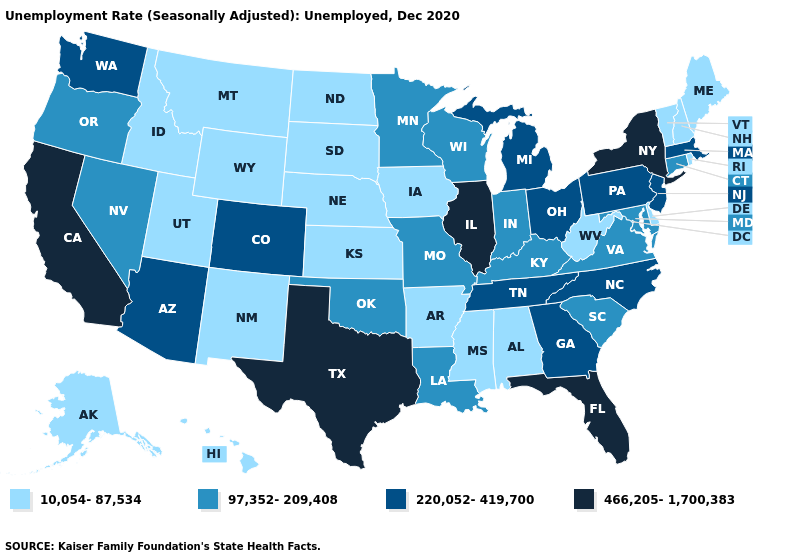Among the states that border Illinois , does Iowa have the lowest value?
Concise answer only. Yes. Name the states that have a value in the range 220,052-419,700?
Short answer required. Arizona, Colorado, Georgia, Massachusetts, Michigan, New Jersey, North Carolina, Ohio, Pennsylvania, Tennessee, Washington. What is the lowest value in states that border Missouri?
Concise answer only. 10,054-87,534. Name the states that have a value in the range 97,352-209,408?
Give a very brief answer. Connecticut, Indiana, Kentucky, Louisiana, Maryland, Minnesota, Missouri, Nevada, Oklahoma, Oregon, South Carolina, Virginia, Wisconsin. Which states have the lowest value in the USA?
Quick response, please. Alabama, Alaska, Arkansas, Delaware, Hawaii, Idaho, Iowa, Kansas, Maine, Mississippi, Montana, Nebraska, New Hampshire, New Mexico, North Dakota, Rhode Island, South Dakota, Utah, Vermont, West Virginia, Wyoming. What is the value of Arizona?
Quick response, please. 220,052-419,700. Does the first symbol in the legend represent the smallest category?
Concise answer only. Yes. Among the states that border Arizona , which have the lowest value?
Answer briefly. New Mexico, Utah. Name the states that have a value in the range 97,352-209,408?
Give a very brief answer. Connecticut, Indiana, Kentucky, Louisiana, Maryland, Minnesota, Missouri, Nevada, Oklahoma, Oregon, South Carolina, Virginia, Wisconsin. Name the states that have a value in the range 220,052-419,700?
Short answer required. Arizona, Colorado, Georgia, Massachusetts, Michigan, New Jersey, North Carolina, Ohio, Pennsylvania, Tennessee, Washington. Which states have the lowest value in the MidWest?
Short answer required. Iowa, Kansas, Nebraska, North Dakota, South Dakota. What is the value of Utah?
Be succinct. 10,054-87,534. Does Colorado have the highest value in the USA?
Be succinct. No. Name the states that have a value in the range 220,052-419,700?
Write a very short answer. Arizona, Colorado, Georgia, Massachusetts, Michigan, New Jersey, North Carolina, Ohio, Pennsylvania, Tennessee, Washington. What is the highest value in the South ?
Concise answer only. 466,205-1,700,383. 